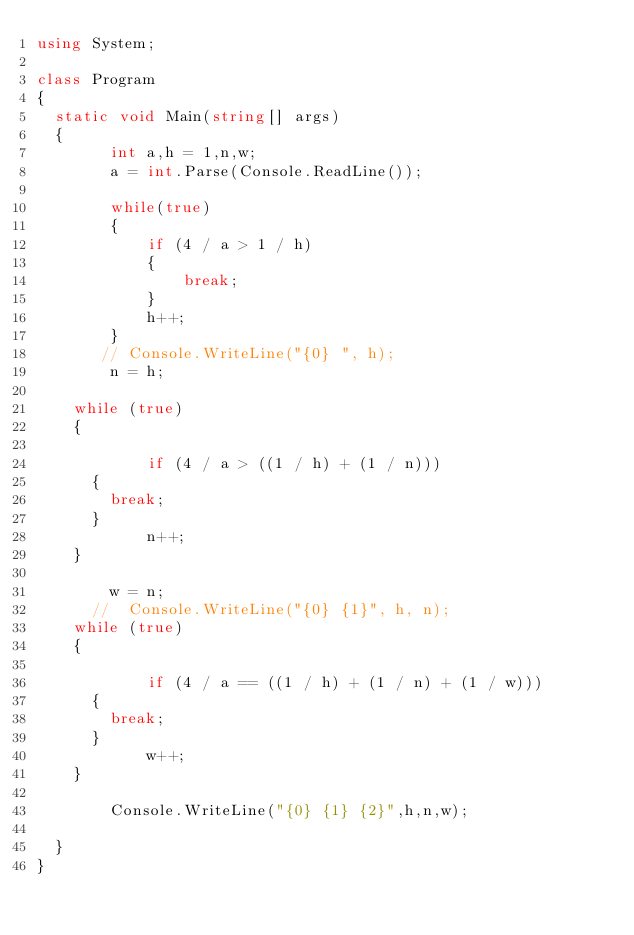Convert code to text. <code><loc_0><loc_0><loc_500><loc_500><_C#_>using System;

class Program
{
	static void Main(string[] args)
	{
        int a,h = 1,n,w;
        a = int.Parse(Console.ReadLine());

        while(true)
        {
            if (4 / a > 1 / h)
            {
                break;
            }
            h++;
        }
       // Console.WriteLine("{0} ", h);
        n = h;

		while (true)
		{
			
            if (4 / a > ((1 / h) + (1 / n)))
			{
				break;
			}
            n++;
		}

        w = n;
      //  Console.WriteLine("{0} {1}", h, n);
		while (true)
		{
			
            if (4 / a == ((1 / h) + (1 / n) + (1 / w)))
			{
				break;
			}
            w++;
		}

        Console.WriteLine("{0} {1} {2}",h,n,w);

	}
}
</code> 